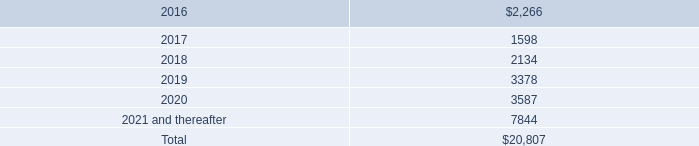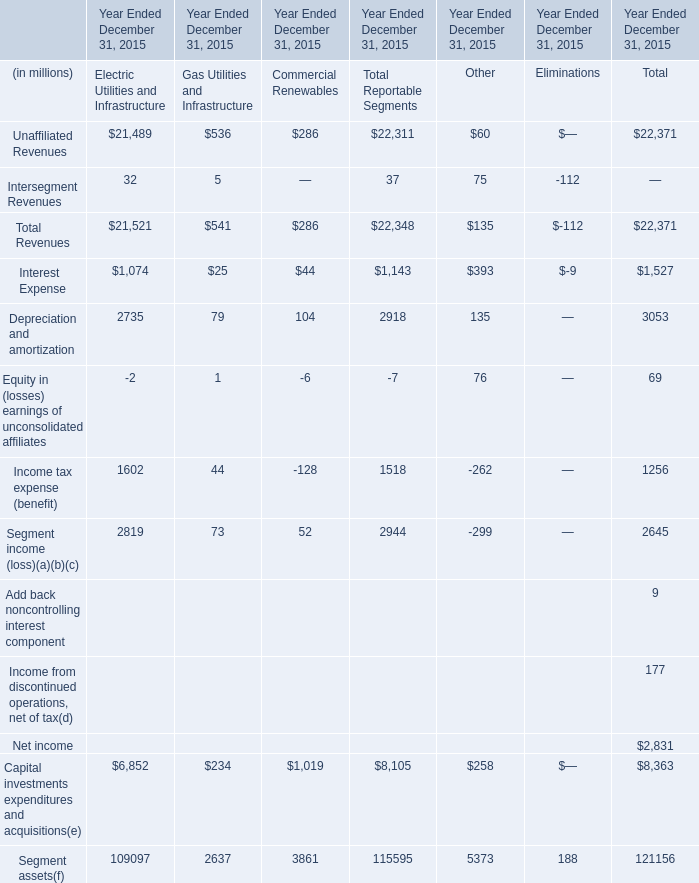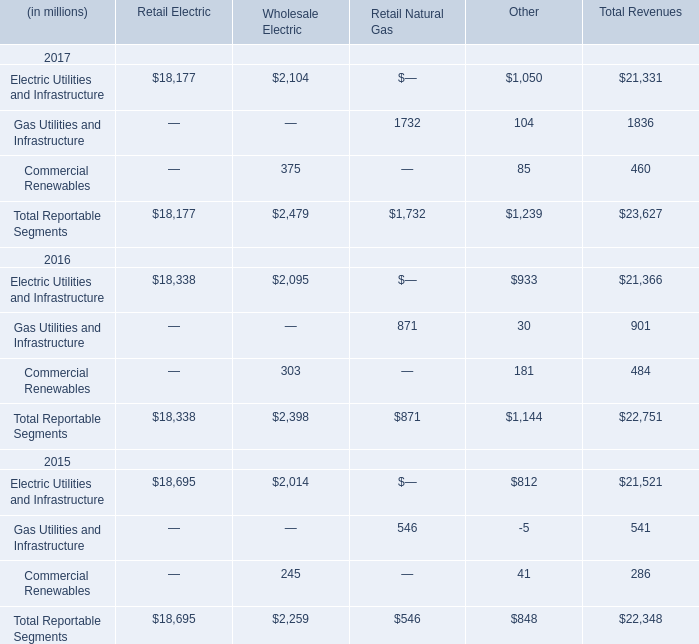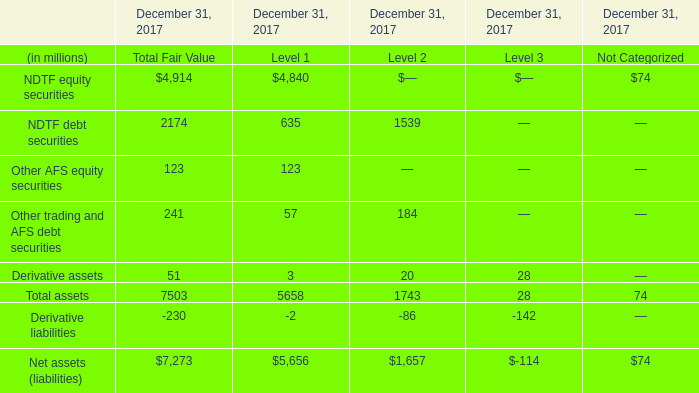What is the average amount of Electric Utilities and Infrastructure of Retail Electric, and Segment assets of Year Ended December 31, 2015 Other ? 
Computations: ((18177.0 + 5373.0) / 2)
Answer: 11775.0. 